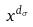<formula> <loc_0><loc_0><loc_500><loc_500>x ^ { d _ { \sigma } }</formula> 